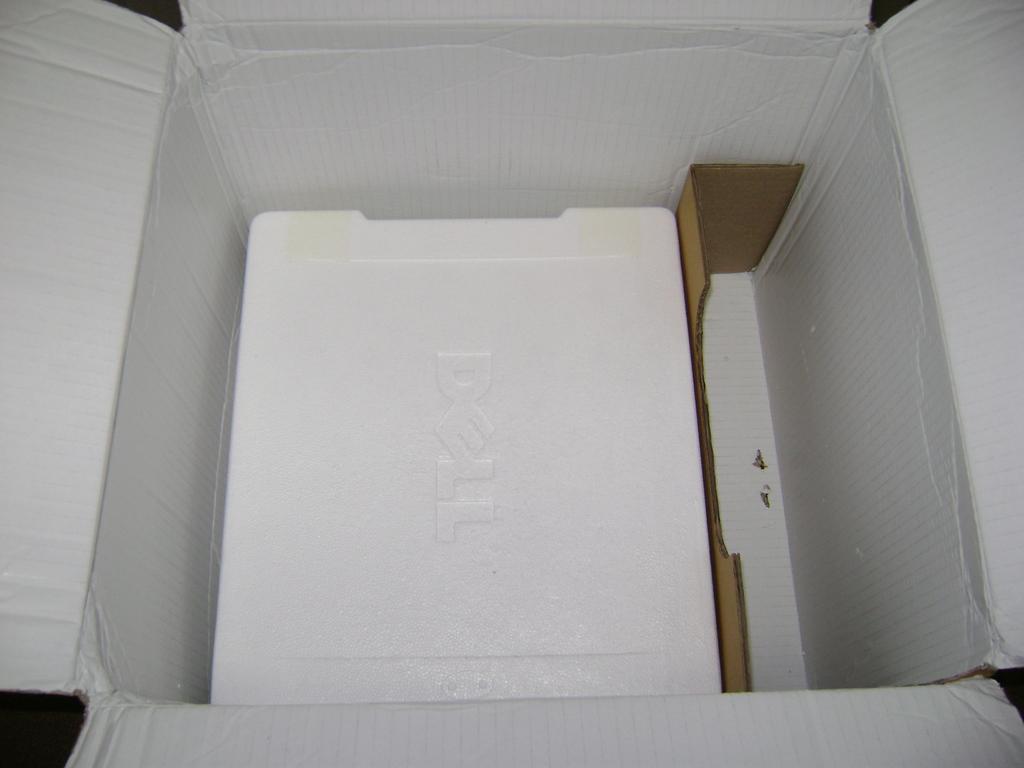What brand is written on the lid?
Ensure brevity in your answer.  Dell. 